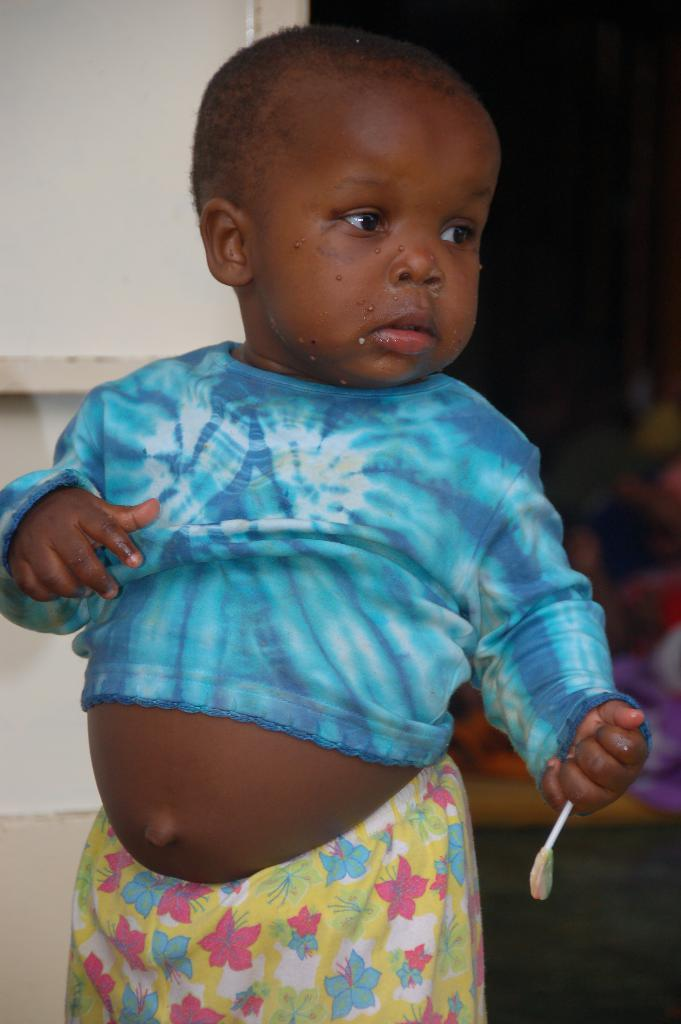What is the main subject of the image? There is a baby in the image. What is the baby doing with their hand? The baby is holding an object in their hand. What position is the baby in? The baby is standing. Which direction is the baby looking? The baby is looking to the right side. What can be seen on the left side of the image? There is a wall on the left side of the image. What is visible in the background of the image? There are objects on the floor in the background of the image. How many dimes are visible on the board in the image? There is no board or dimes present in the image. 